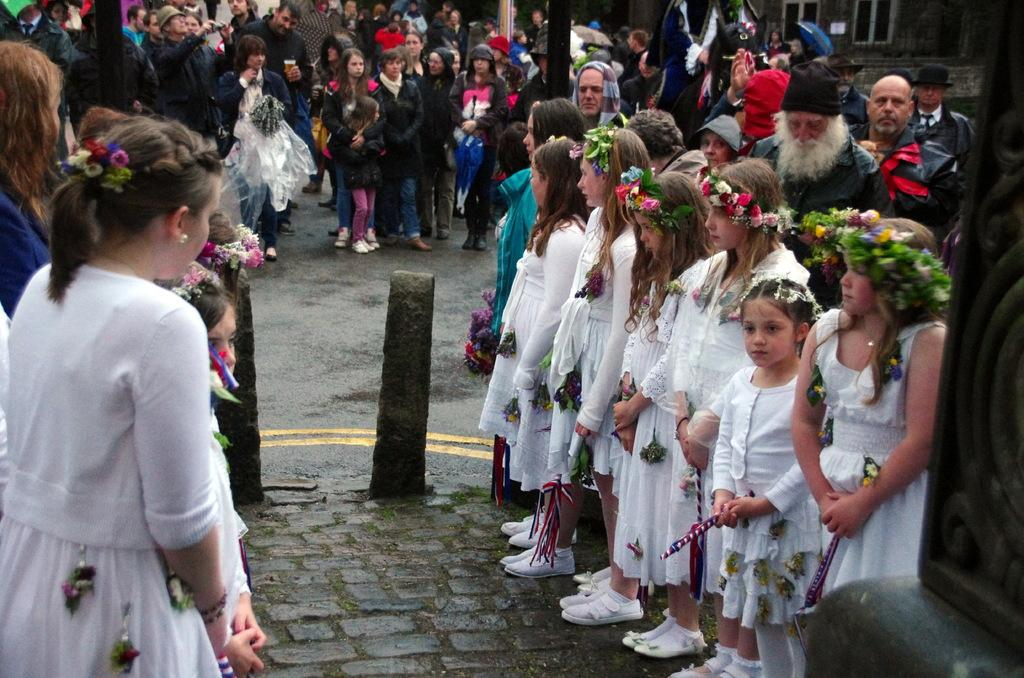What are the people in the image doing? The group of people is standing on the ground. What type of natural elements can be seen in the image? Stones are present in the image. What else can be seen in the image besides the people and stones? There are objects in the image. What can be seen in the background of the image? There is an umbrella, windows, and a wall visible in the background. What grade is the ant in the image? There is no ant present in the image, so it is not possible to determine its grade. 